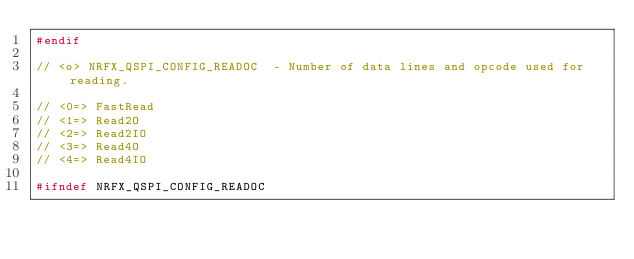<code> <loc_0><loc_0><loc_500><loc_500><_C_>#endif

// <o> NRFX_QSPI_CONFIG_READOC  - Number of data lines and opcode used for reading.
 
// <0=> FastRead 
// <1=> Read2O 
// <2=> Read2IO 
// <3=> Read4O 
// <4=> Read4IO 

#ifndef NRFX_QSPI_CONFIG_READOC</code> 